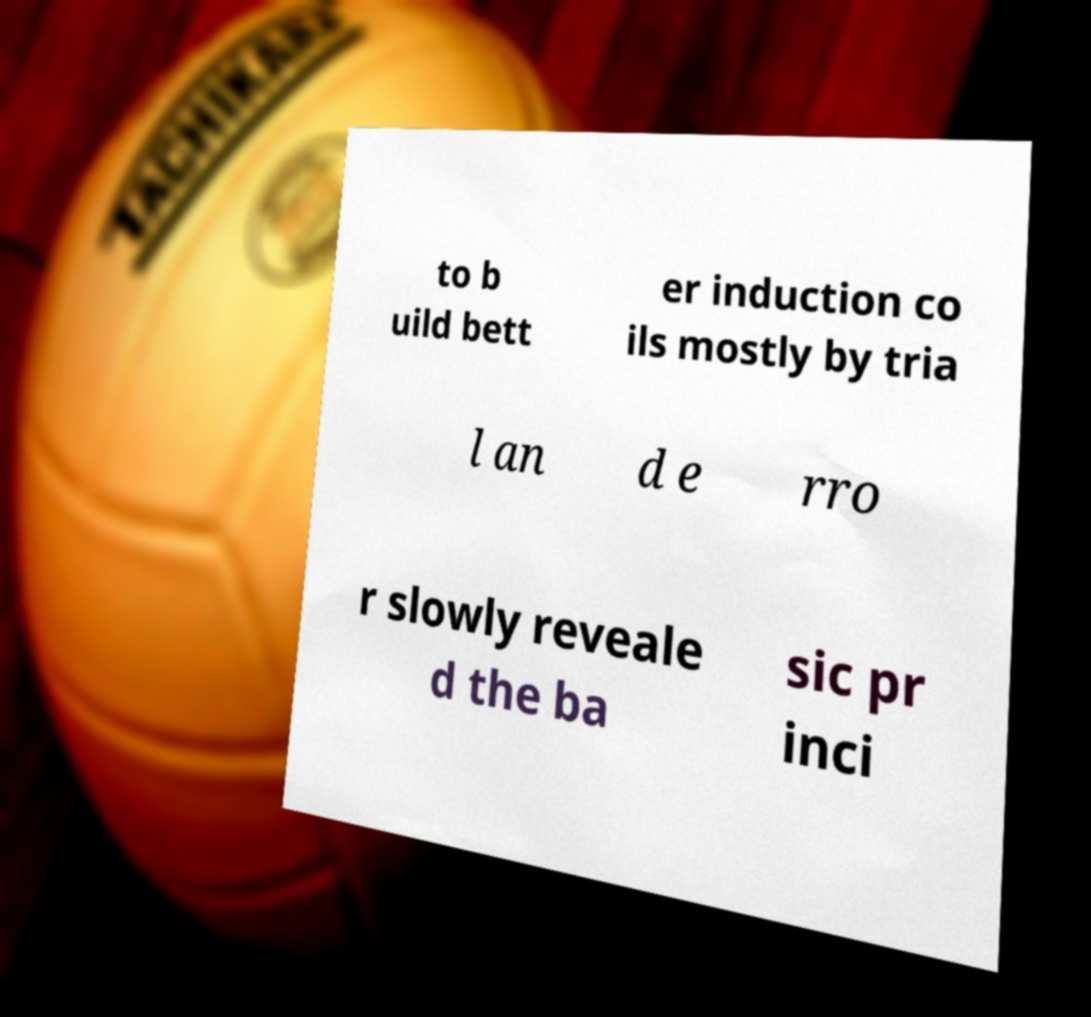I need the written content from this picture converted into text. Can you do that? to b uild bett er induction co ils mostly by tria l an d e rro r slowly reveale d the ba sic pr inci 